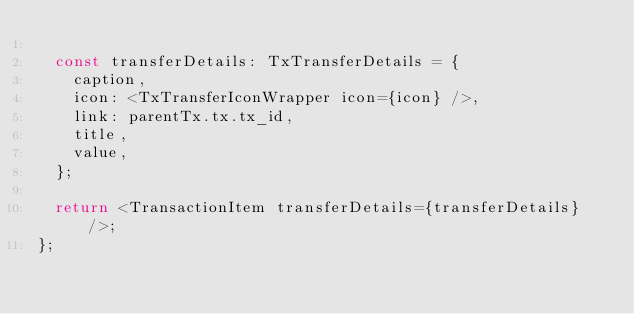Convert code to text. <code><loc_0><loc_0><loc_500><loc_500><_TypeScript_>
  const transferDetails: TxTransferDetails = {
    caption,
    icon: <TxTransferIconWrapper icon={icon} />,
    link: parentTx.tx.tx_id,
    title,
    value,
  };

  return <TransactionItem transferDetails={transferDetails} />;
};
</code> 